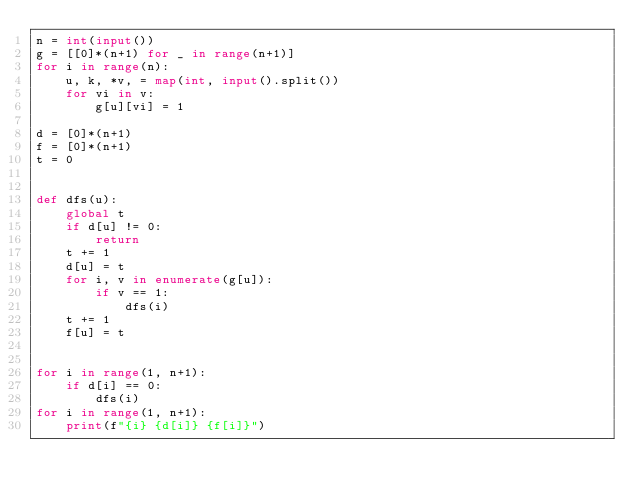<code> <loc_0><loc_0><loc_500><loc_500><_Python_>n = int(input())
g = [[0]*(n+1) for _ in range(n+1)]
for i in range(n):
    u, k, *v, = map(int, input().split())
    for vi in v:
        g[u][vi] = 1

d = [0]*(n+1)
f = [0]*(n+1)
t = 0


def dfs(u):
    global t
    if d[u] != 0:
        return
    t += 1
    d[u] = t
    for i, v in enumerate(g[u]):
        if v == 1:
            dfs(i)
    t += 1
    f[u] = t


for i in range(1, n+1):
    if d[i] == 0:
        dfs(i)
for i in range(1, n+1):
    print(f"{i} {d[i]} {f[i]}")

</code> 